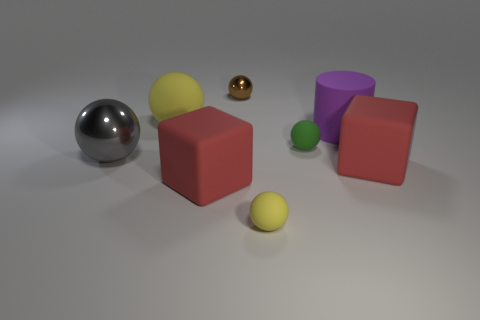Subtract all big shiny balls. How many balls are left? 4 Subtract all green spheres. How many spheres are left? 4 Subtract all cylinders. How many objects are left? 7 Subtract all gray cylinders. How many gray spheres are left? 1 Subtract all gray metallic things. Subtract all purple things. How many objects are left? 6 Add 8 brown metal things. How many brown metal things are left? 9 Add 5 big gray rubber things. How many big gray rubber things exist? 5 Add 2 tiny green spheres. How many objects exist? 10 Subtract 0 purple cubes. How many objects are left? 8 Subtract 2 blocks. How many blocks are left? 0 